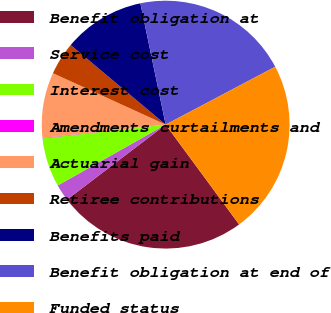<chart> <loc_0><loc_0><loc_500><loc_500><pie_chart><fcel>Benefit obligation at<fcel>Service cost<fcel>Interest cost<fcel>Amendments curtailments and<fcel>Actuarial gain<fcel>Retiree contributions<fcel>Benefits paid<fcel>Benefit obligation at end of<fcel>Funded status<nl><fcel>24.75%<fcel>2.18%<fcel>6.4%<fcel>0.06%<fcel>8.52%<fcel>4.29%<fcel>10.63%<fcel>20.53%<fcel>22.64%<nl></chart> 